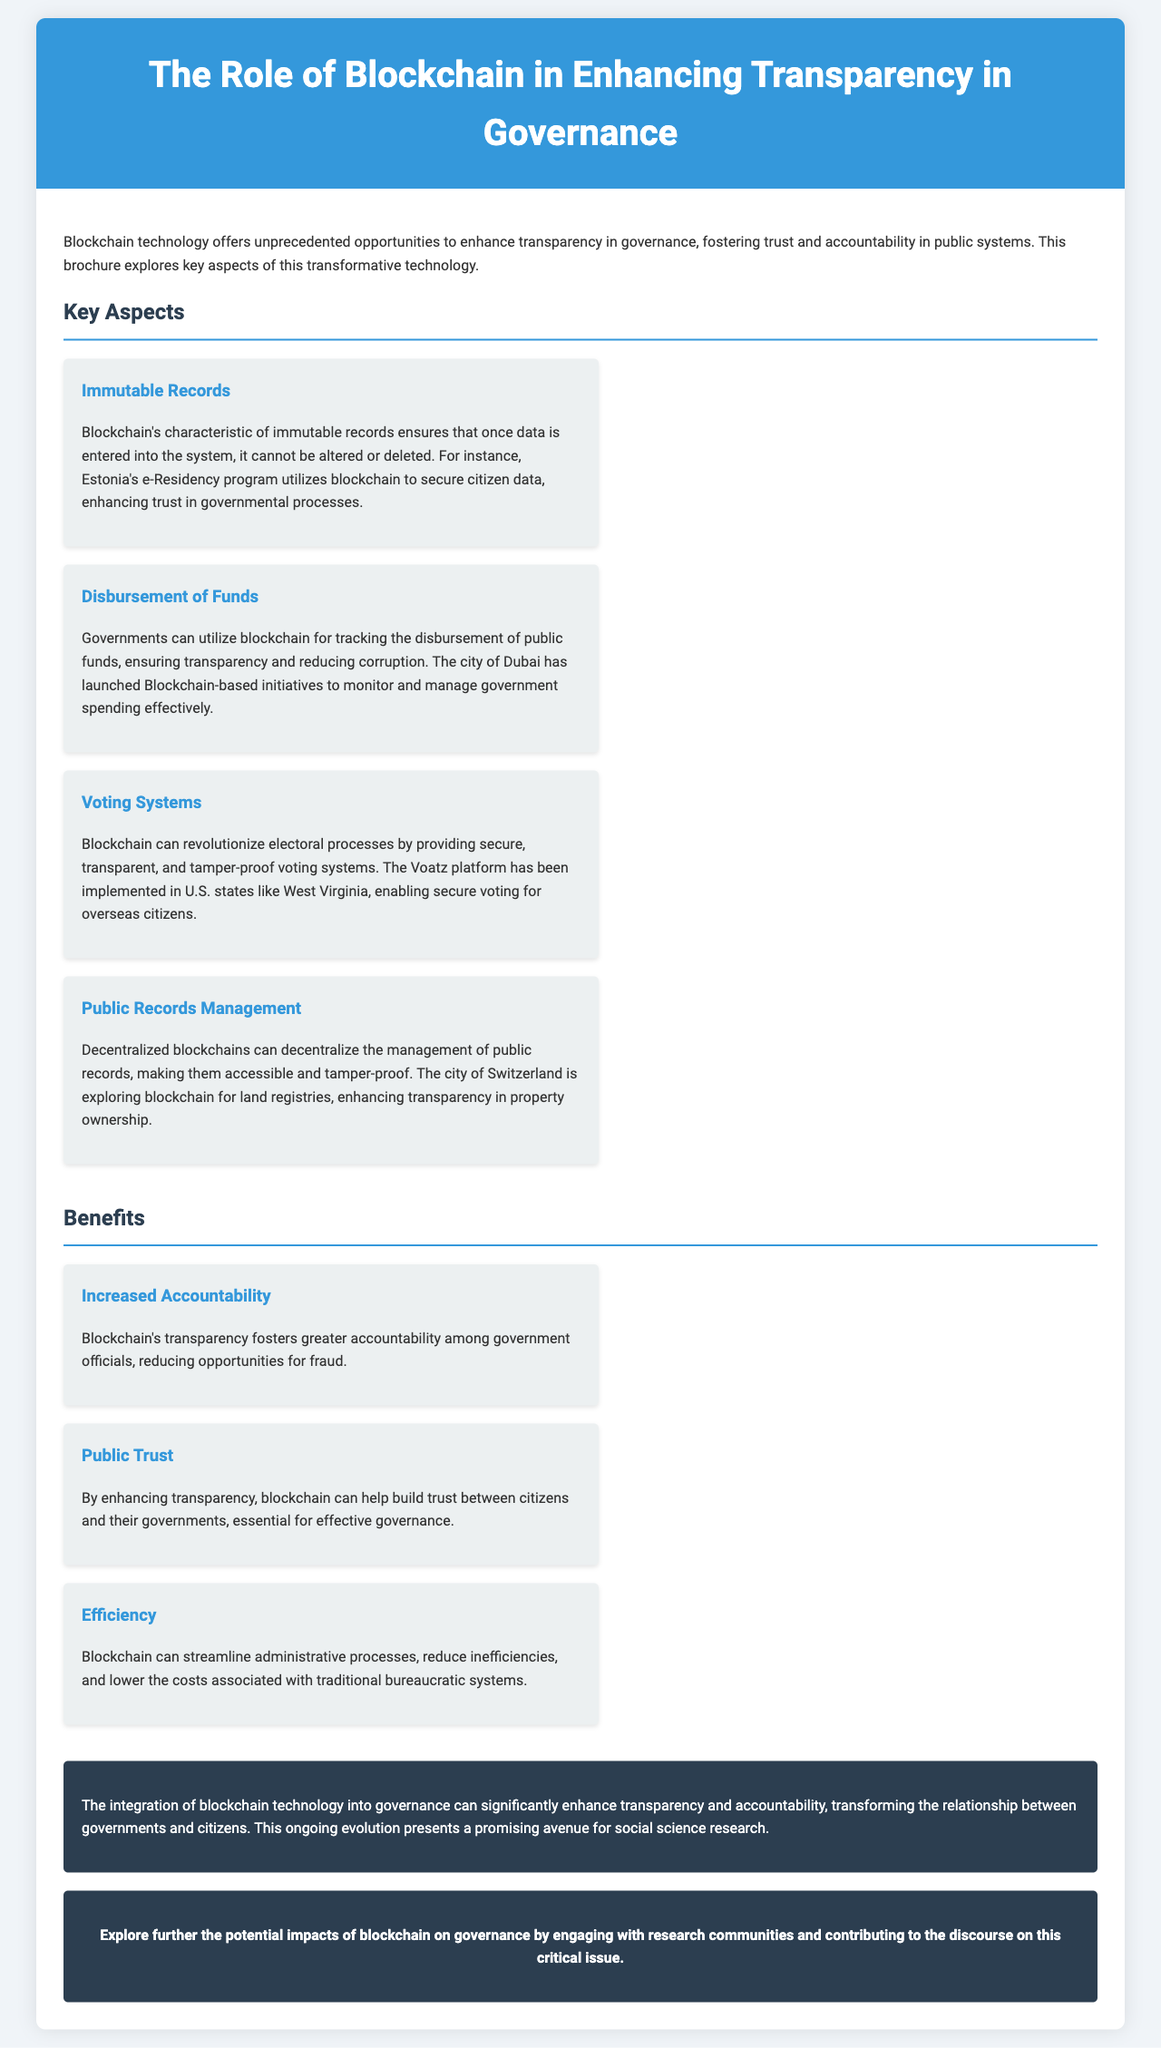What is the title of the brochure? The title of the brochure is stated prominently at the top and indicates the main topic covered.
Answer: The Role of Blockchain in Enhancing Transparency in Governance What characteristic of blockchain ensures data cannot be altered once entered? This characteristic is mentioned to highlight the reliability of the data stored in the blockchain system.
Answer: Immutable Records Which city launched Blockchain-based initiatives to monitor government spending? This city is referred to in the section discussing the tracking of public funds and their transparency efforts.
Answer: Dubai What benefit does blockchain provide by fostering greater accountability among officials? This benefit is described in the section focusing on the advantages of using blockchain in governance.
Answer: Increased Accountability What platform has been implemented in U.S. states to enable secure voting for overseas citizens? This platform is mentioned in the voting systems aspect of the document as an example of blockchain use.
Answer: Voatz In which country is there exploration of using blockchain for land registries? This country is mentioned in the public records management aspect as a use case for enhanced transparency.
Answer: Switzerland What is highlighted as essential for effective governance in terms of public relations? This aspect deals with the relationship between citizens and their governments, aimed at building mutual trust.
Answer: Public Trust What is the main conclusion about blockchain’s role in governance? This conclusion summarizes the overall impact blockchain technology could have on government-citizen relationships.
Answer: Enhance transparency and accountability What audience is encouraged to engage with the discourse on blockchain's impacts? This audience is specified in the call-to-action section, encouraging participation in the ongoing research.
Answer: Research communities 